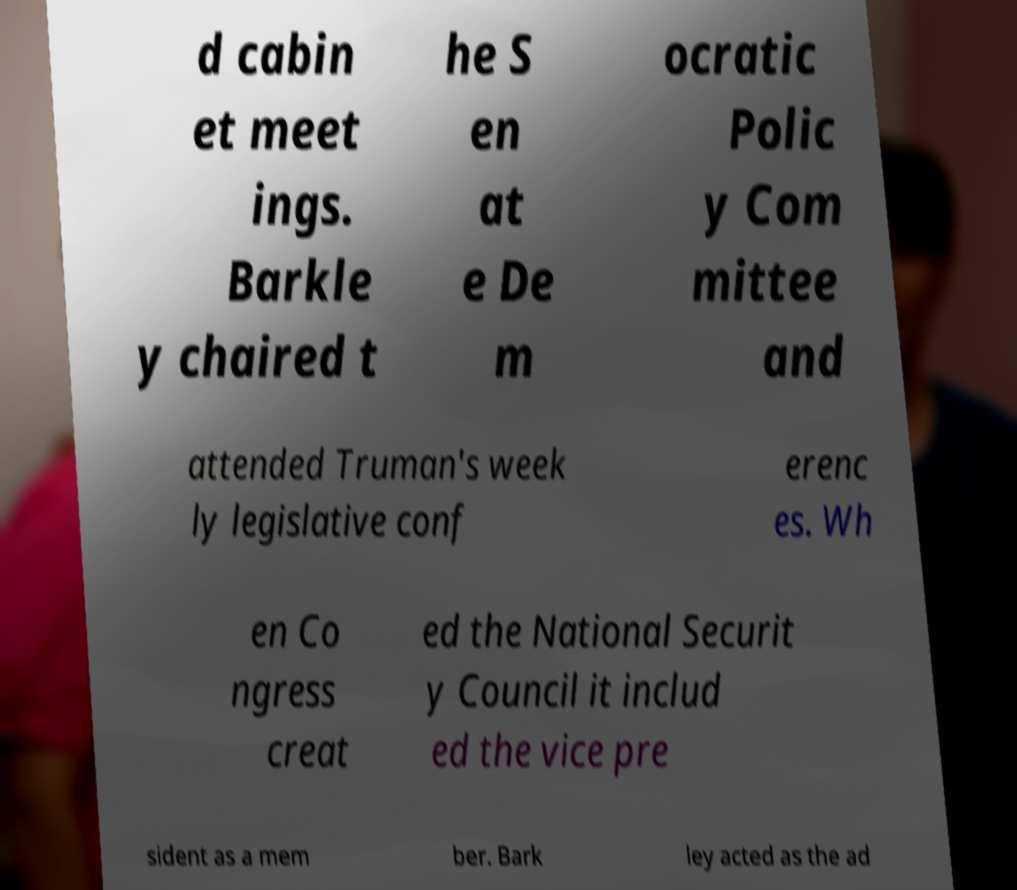There's text embedded in this image that I need extracted. Can you transcribe it verbatim? d cabin et meet ings. Barkle y chaired t he S en at e De m ocratic Polic y Com mittee and attended Truman's week ly legislative conf erenc es. Wh en Co ngress creat ed the National Securit y Council it includ ed the vice pre sident as a mem ber. Bark ley acted as the ad 